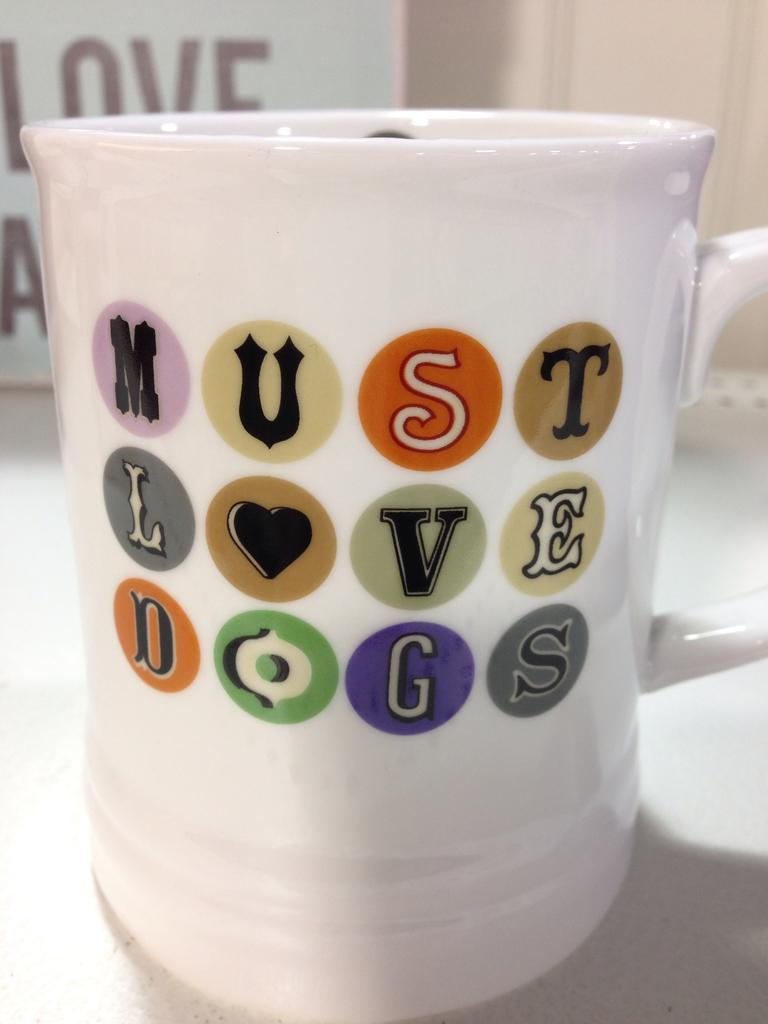What is on the cup that is visible in the image? There is text on the cup that is visible in the image. Where is the cup located in the image? The cup is placed on a table in the image. What else in the image has text on it? There is a board with text in the image. What type of breakfast is being served on the tray in the image? There is no tray or breakfast present in the image; it only features a cup and a board with text. How does the text on the cup enter the mouth in the image? The text on the cup does not enter the mouth in the image; it is simply printed on the cup. 